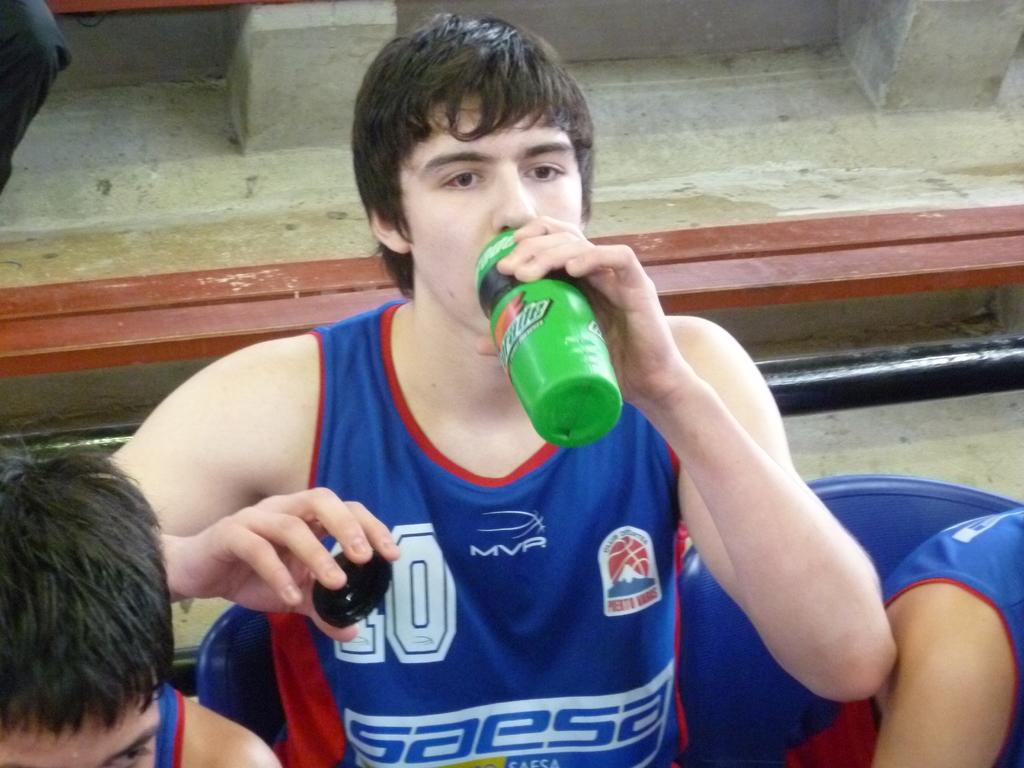<image>
Share a concise interpretation of the image provided. A man wearing a shirt reading SAESA has a drink. 